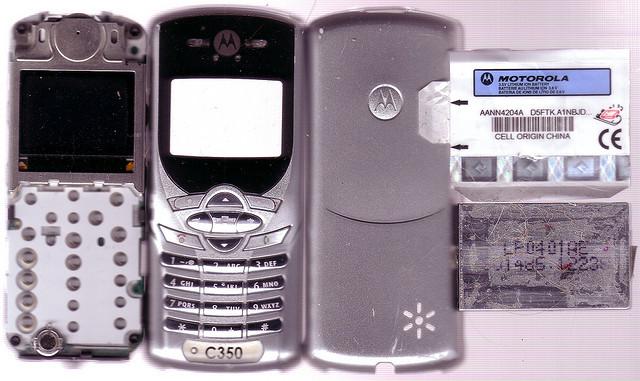What is mainly featured?
Be succinct. Cell phone. Is this yours?
Write a very short answer. No. Does this phone allow picture messaging?
Write a very short answer. Yes. Is this an Android?
Concise answer only. No. 